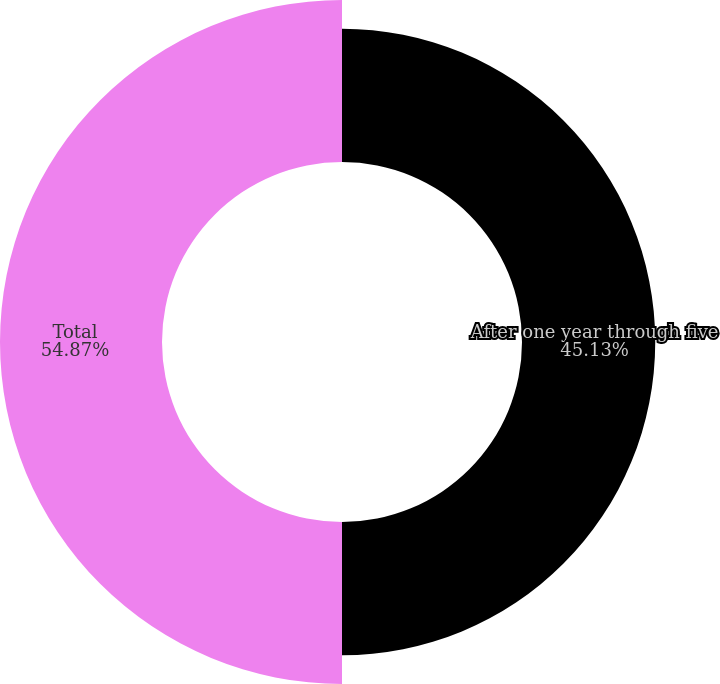Convert chart. <chart><loc_0><loc_0><loc_500><loc_500><pie_chart><fcel>After one year through five<fcel>Total<nl><fcel>45.13%<fcel>54.87%<nl></chart> 